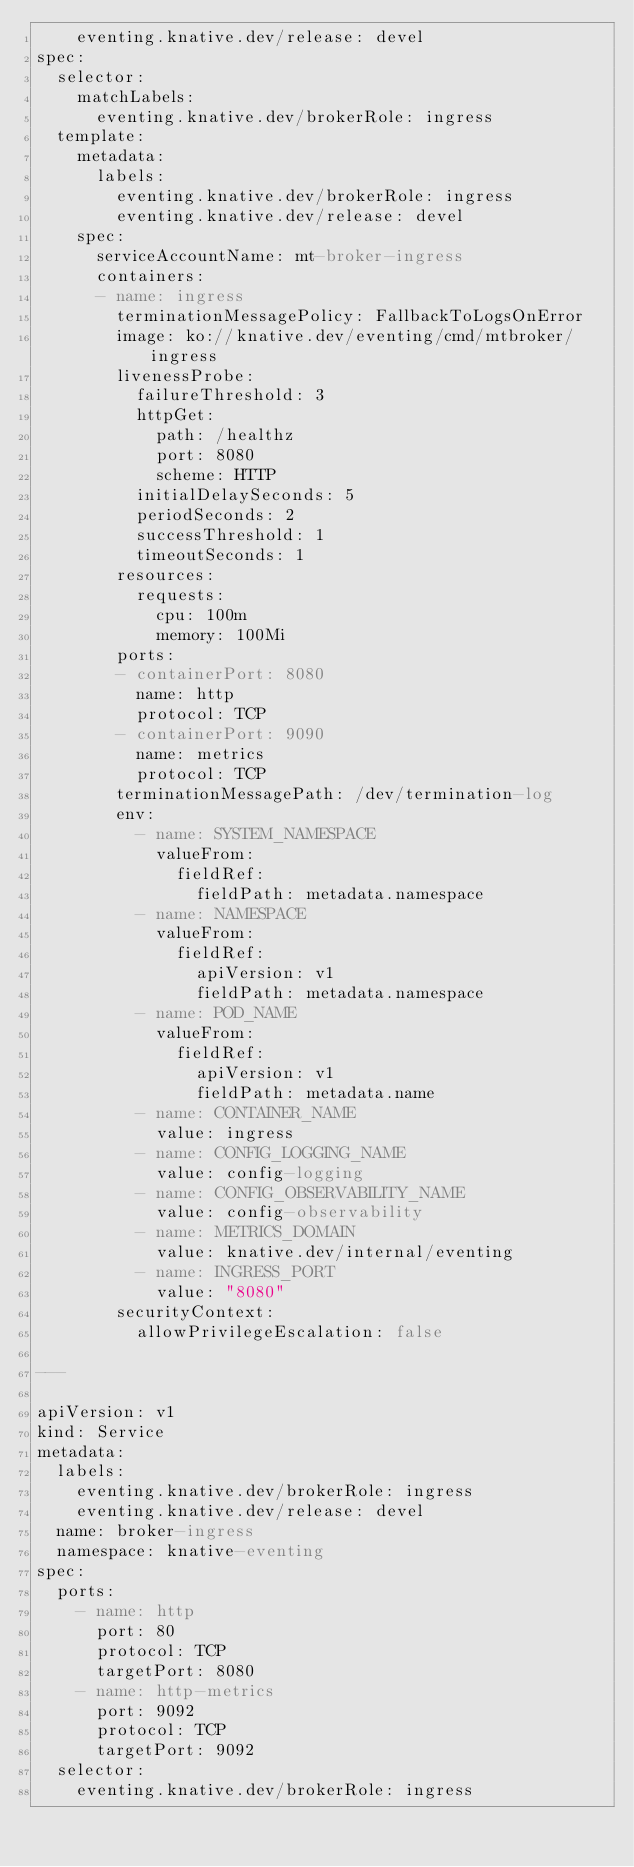Convert code to text. <code><loc_0><loc_0><loc_500><loc_500><_YAML_>    eventing.knative.dev/release: devel
spec:
  selector:
    matchLabels:
      eventing.knative.dev/brokerRole: ingress
  template:
    metadata:
      labels:
        eventing.knative.dev/brokerRole: ingress
        eventing.knative.dev/release: devel
    spec:
      serviceAccountName: mt-broker-ingress
      containers:
      - name: ingress
        terminationMessagePolicy: FallbackToLogsOnError
        image: ko://knative.dev/eventing/cmd/mtbroker/ingress
        livenessProbe:
          failureThreshold: 3
          httpGet:
            path: /healthz
            port: 8080
            scheme: HTTP
          initialDelaySeconds: 5
          periodSeconds: 2
          successThreshold: 1
          timeoutSeconds: 1
        resources:
          requests:
            cpu: 100m
            memory: 100Mi
        ports:
        - containerPort: 8080
          name: http
          protocol: TCP
        - containerPort: 9090
          name: metrics
          protocol: TCP
        terminationMessagePath: /dev/termination-log
        env:
          - name: SYSTEM_NAMESPACE
            valueFrom:
              fieldRef:
                fieldPath: metadata.namespace
          - name: NAMESPACE
            valueFrom:
              fieldRef:
                apiVersion: v1
                fieldPath: metadata.namespace
          - name: POD_NAME
            valueFrom:
              fieldRef:
                apiVersion: v1
                fieldPath: metadata.name
          - name: CONTAINER_NAME
            value: ingress
          - name: CONFIG_LOGGING_NAME
            value: config-logging
          - name: CONFIG_OBSERVABILITY_NAME
            value: config-observability
          - name: METRICS_DOMAIN
            value: knative.dev/internal/eventing
          - name: INGRESS_PORT
            value: "8080"
        securityContext:
          allowPrivilegeEscalation: false

---

apiVersion: v1
kind: Service
metadata:
  labels:
    eventing.knative.dev/brokerRole: ingress
    eventing.knative.dev/release: devel
  name: broker-ingress
  namespace: knative-eventing
spec:
  ports:
    - name: http
      port: 80
      protocol: TCP
      targetPort: 8080
    - name: http-metrics
      port: 9092
      protocol: TCP
      targetPort: 9092
  selector:
    eventing.knative.dev/brokerRole: ingress
</code> 